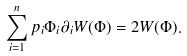<formula> <loc_0><loc_0><loc_500><loc_500>\sum _ { i = 1 } ^ { n } p _ { i } \Phi _ { i } \partial _ { i } W ( \Phi ) = 2 W ( \Phi ) .</formula> 